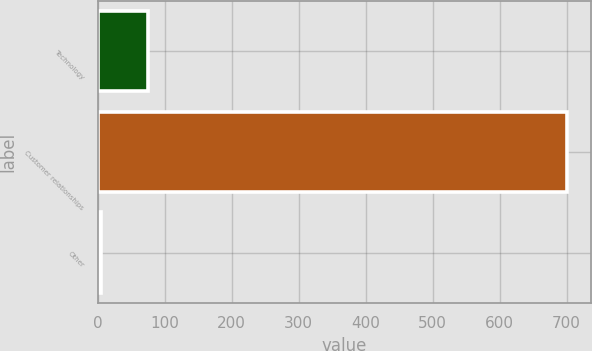Convert chart. <chart><loc_0><loc_0><loc_500><loc_500><bar_chart><fcel>Technology<fcel>Customer relationships<fcel>Other<nl><fcel>74.6<fcel>701<fcel>5<nl></chart> 